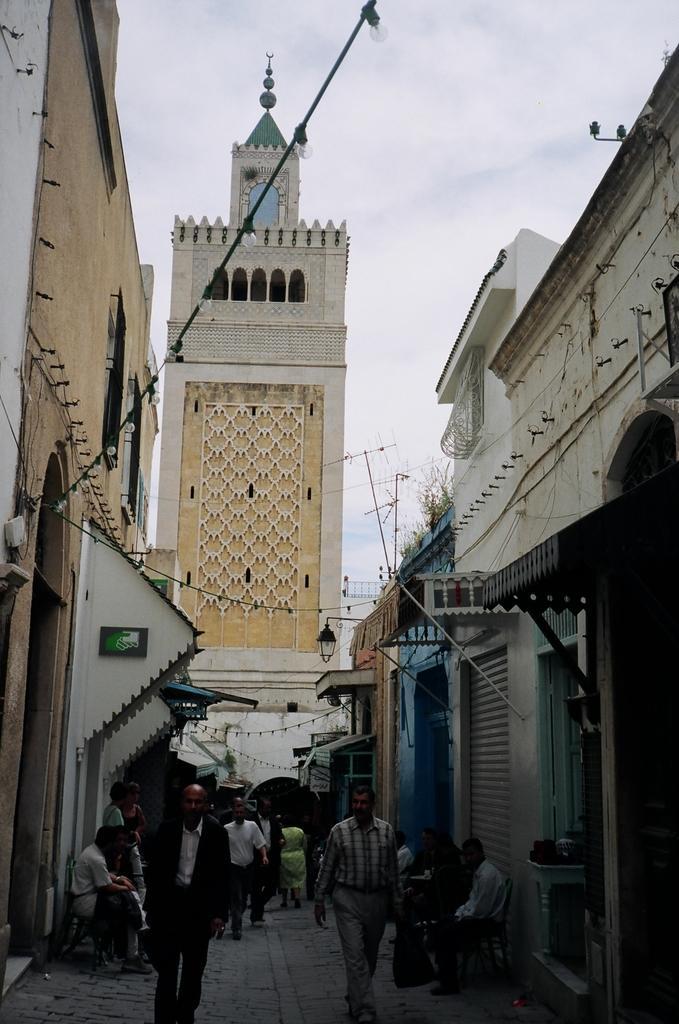Describe this image in one or two sentences. Few people sitting and few people walking and we can see lights. We can see wall,buildings and tower. Background we can see sky. 